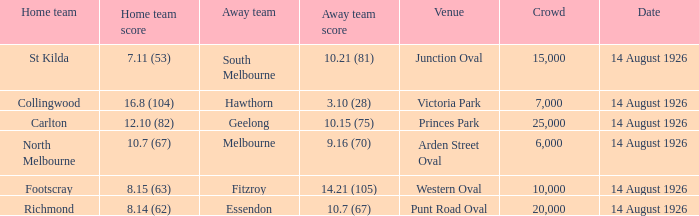What was the average crowd at Western Oval? 10000.0. 